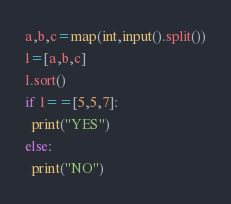Convert code to text. <code><loc_0><loc_0><loc_500><loc_500><_Python_>a,b,c=map(int,input().split())
l=[a,b,c]
l.sort()
if l==[5,5,7]:
  print("YES")
else:
  print("NO")

</code> 